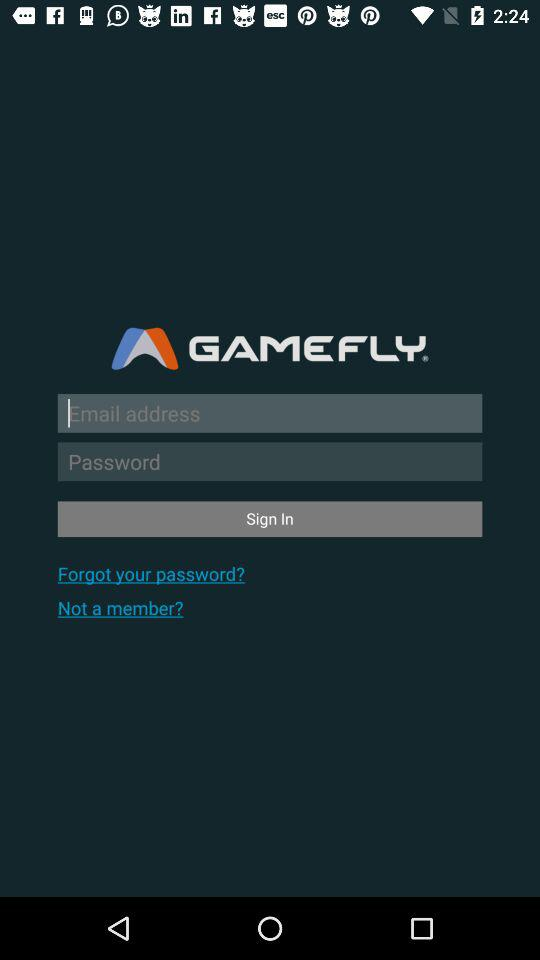What is the name of the application? The application name is "GAMEFLY". 